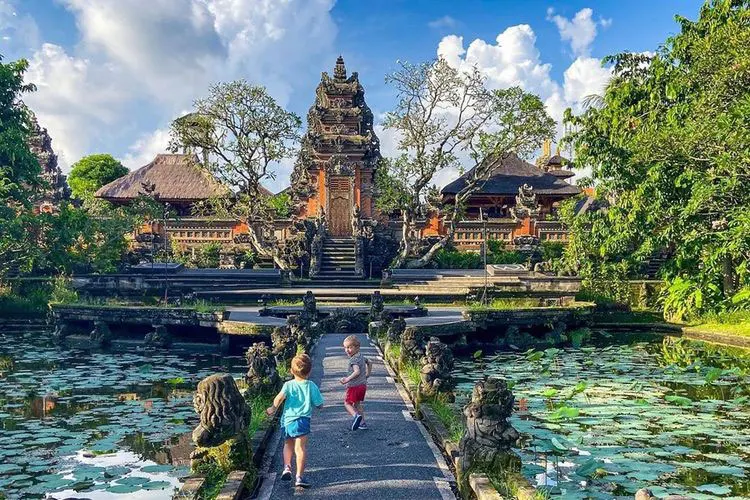What significance do the gardens and water features hold in this setting? The gardens and water features play a crucial role in the overall design and spiritual significance of the Ubud Water Palace. The lush gardens symbolize life and fertility, reflecting the Balinese reverence for nature. Water features, such as ponds and fountains, are integral to Balinese architecture for their aesthetic beauty and their role in purification rituals. They also create a calming ambiance that enhances meditation and reflection, which are important aspects of Balinese Hindu culture. 